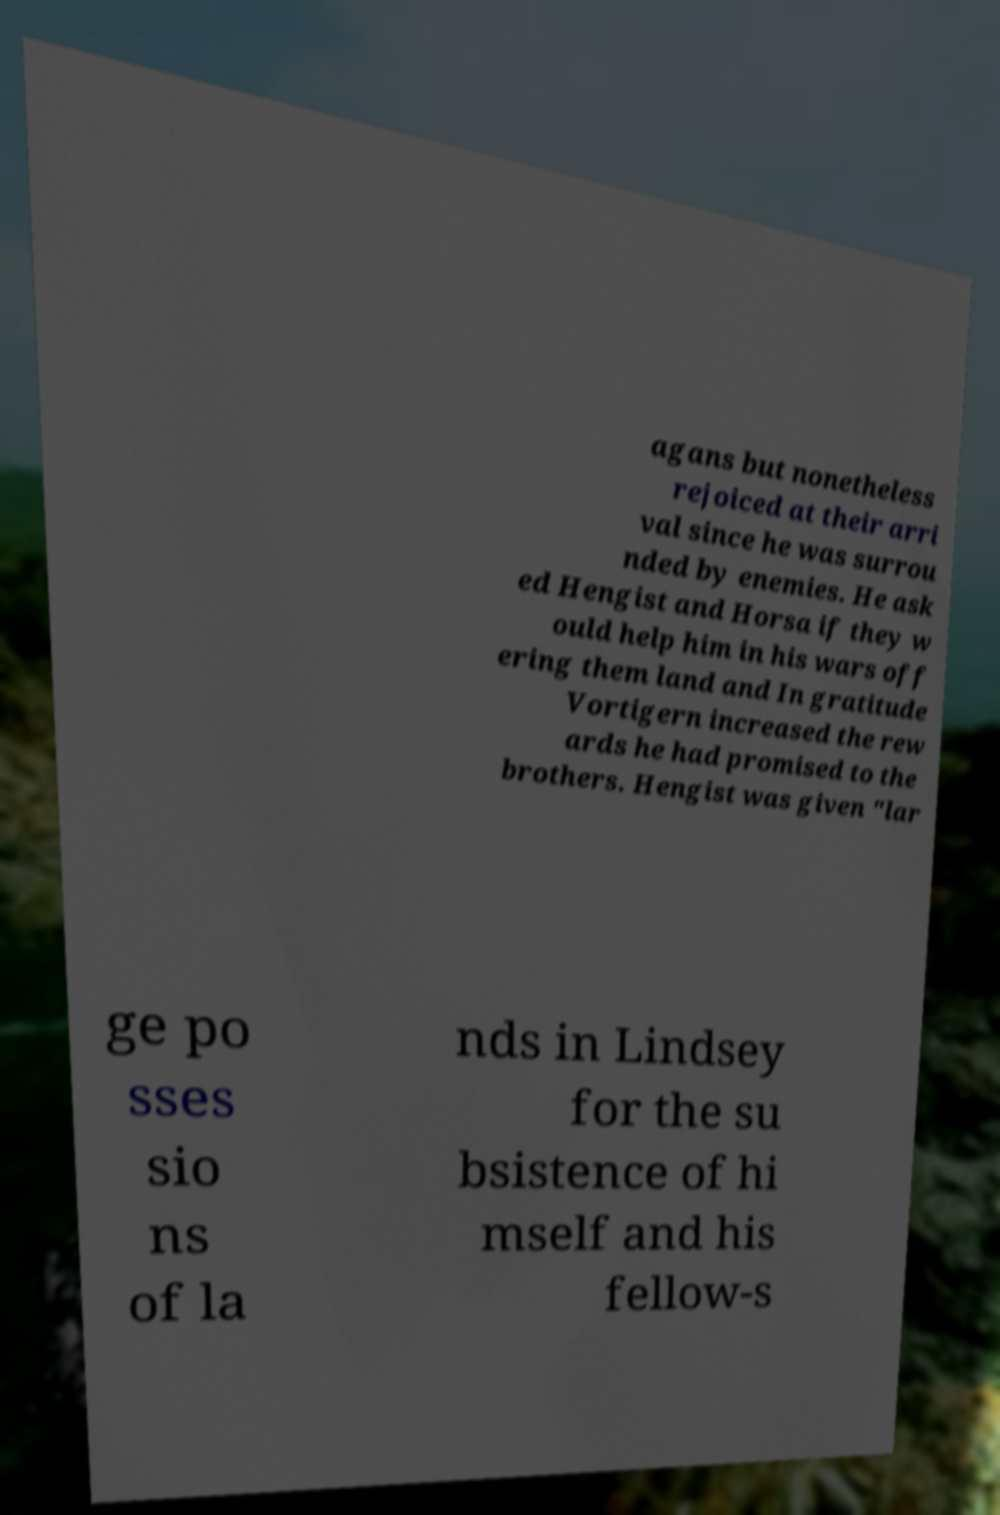There's text embedded in this image that I need extracted. Can you transcribe it verbatim? agans but nonetheless rejoiced at their arri val since he was surrou nded by enemies. He ask ed Hengist and Horsa if they w ould help him in his wars off ering them land and In gratitude Vortigern increased the rew ards he had promised to the brothers. Hengist was given "lar ge po sses sio ns of la nds in Lindsey for the su bsistence of hi mself and his fellow-s 